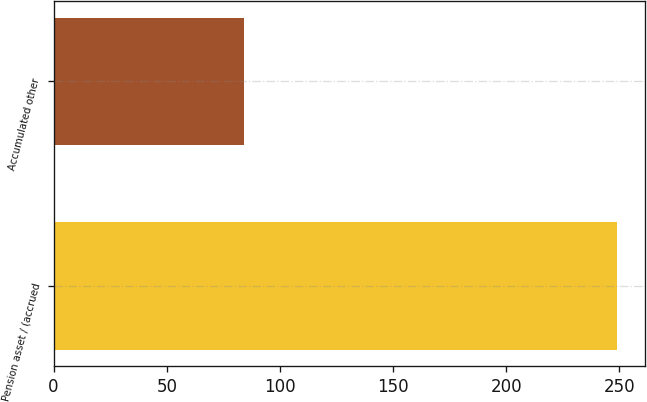Convert chart. <chart><loc_0><loc_0><loc_500><loc_500><bar_chart><fcel>Pension asset / (accrued<fcel>Accumulated other<nl><fcel>249<fcel>84<nl></chart> 